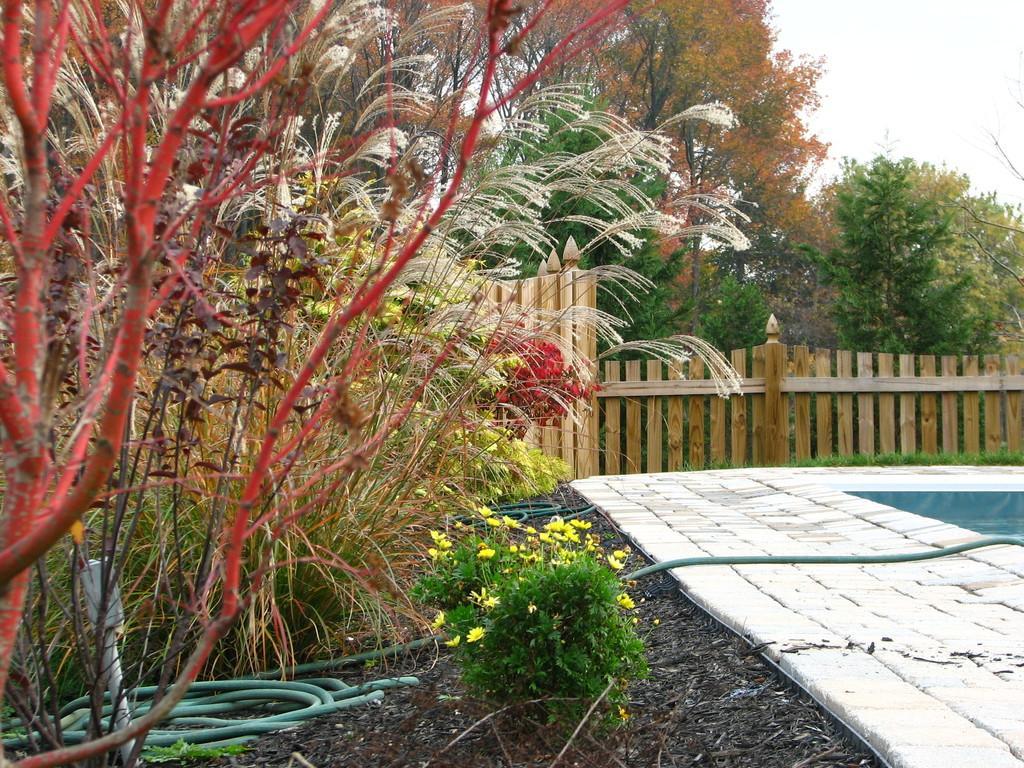In one or two sentences, can you explain what this image depicts? In this image, we can see so many plants, trees, wooden fencing. Right side of the image, we can see a walkway. Here we can see a pipe, flowers. 